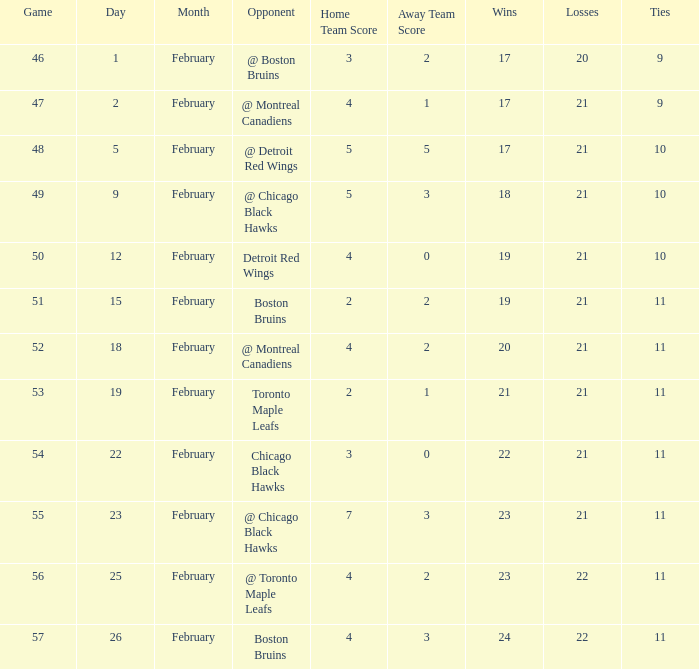What is the score of the game before 56 held after February 18 against the Chicago Black Hawks. 3 - 0. 